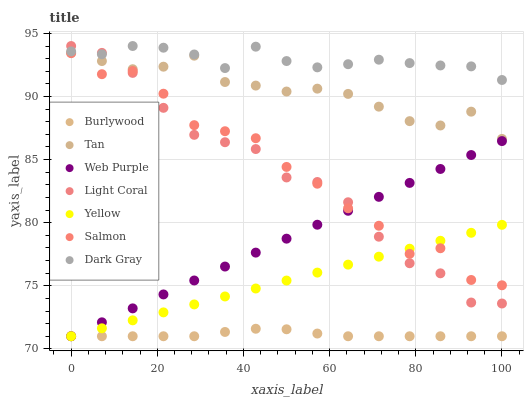Does Burlywood have the minimum area under the curve?
Answer yes or no. Yes. Does Dark Gray have the maximum area under the curve?
Answer yes or no. Yes. Does Salmon have the minimum area under the curve?
Answer yes or no. No. Does Salmon have the maximum area under the curve?
Answer yes or no. No. Is Yellow the smoothest?
Answer yes or no. Yes. Is Salmon the roughest?
Answer yes or no. Yes. Is Burlywood the smoothest?
Answer yes or no. No. Is Burlywood the roughest?
Answer yes or no. No. Does Burlywood have the lowest value?
Answer yes or no. Yes. Does Salmon have the lowest value?
Answer yes or no. No. Does Light Coral have the highest value?
Answer yes or no. Yes. Does Salmon have the highest value?
Answer yes or no. No. Is Tan less than Dark Gray?
Answer yes or no. Yes. Is Dark Gray greater than Tan?
Answer yes or no. Yes. Does Light Coral intersect Dark Gray?
Answer yes or no. Yes. Is Light Coral less than Dark Gray?
Answer yes or no. No. Is Light Coral greater than Dark Gray?
Answer yes or no. No. Does Tan intersect Dark Gray?
Answer yes or no. No. 